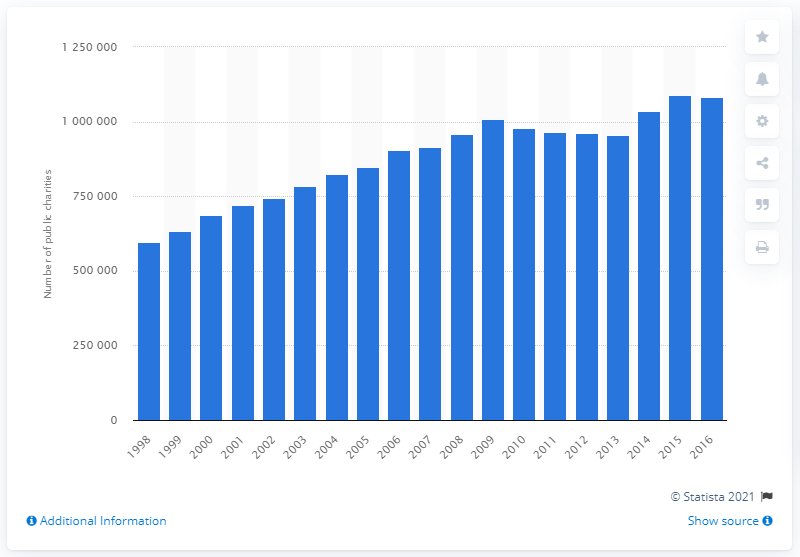Mention a couple of crucial points in this snapshot. In the year 2016, a total of 1081969 public charities were registered with the Internal Revenue Service. 